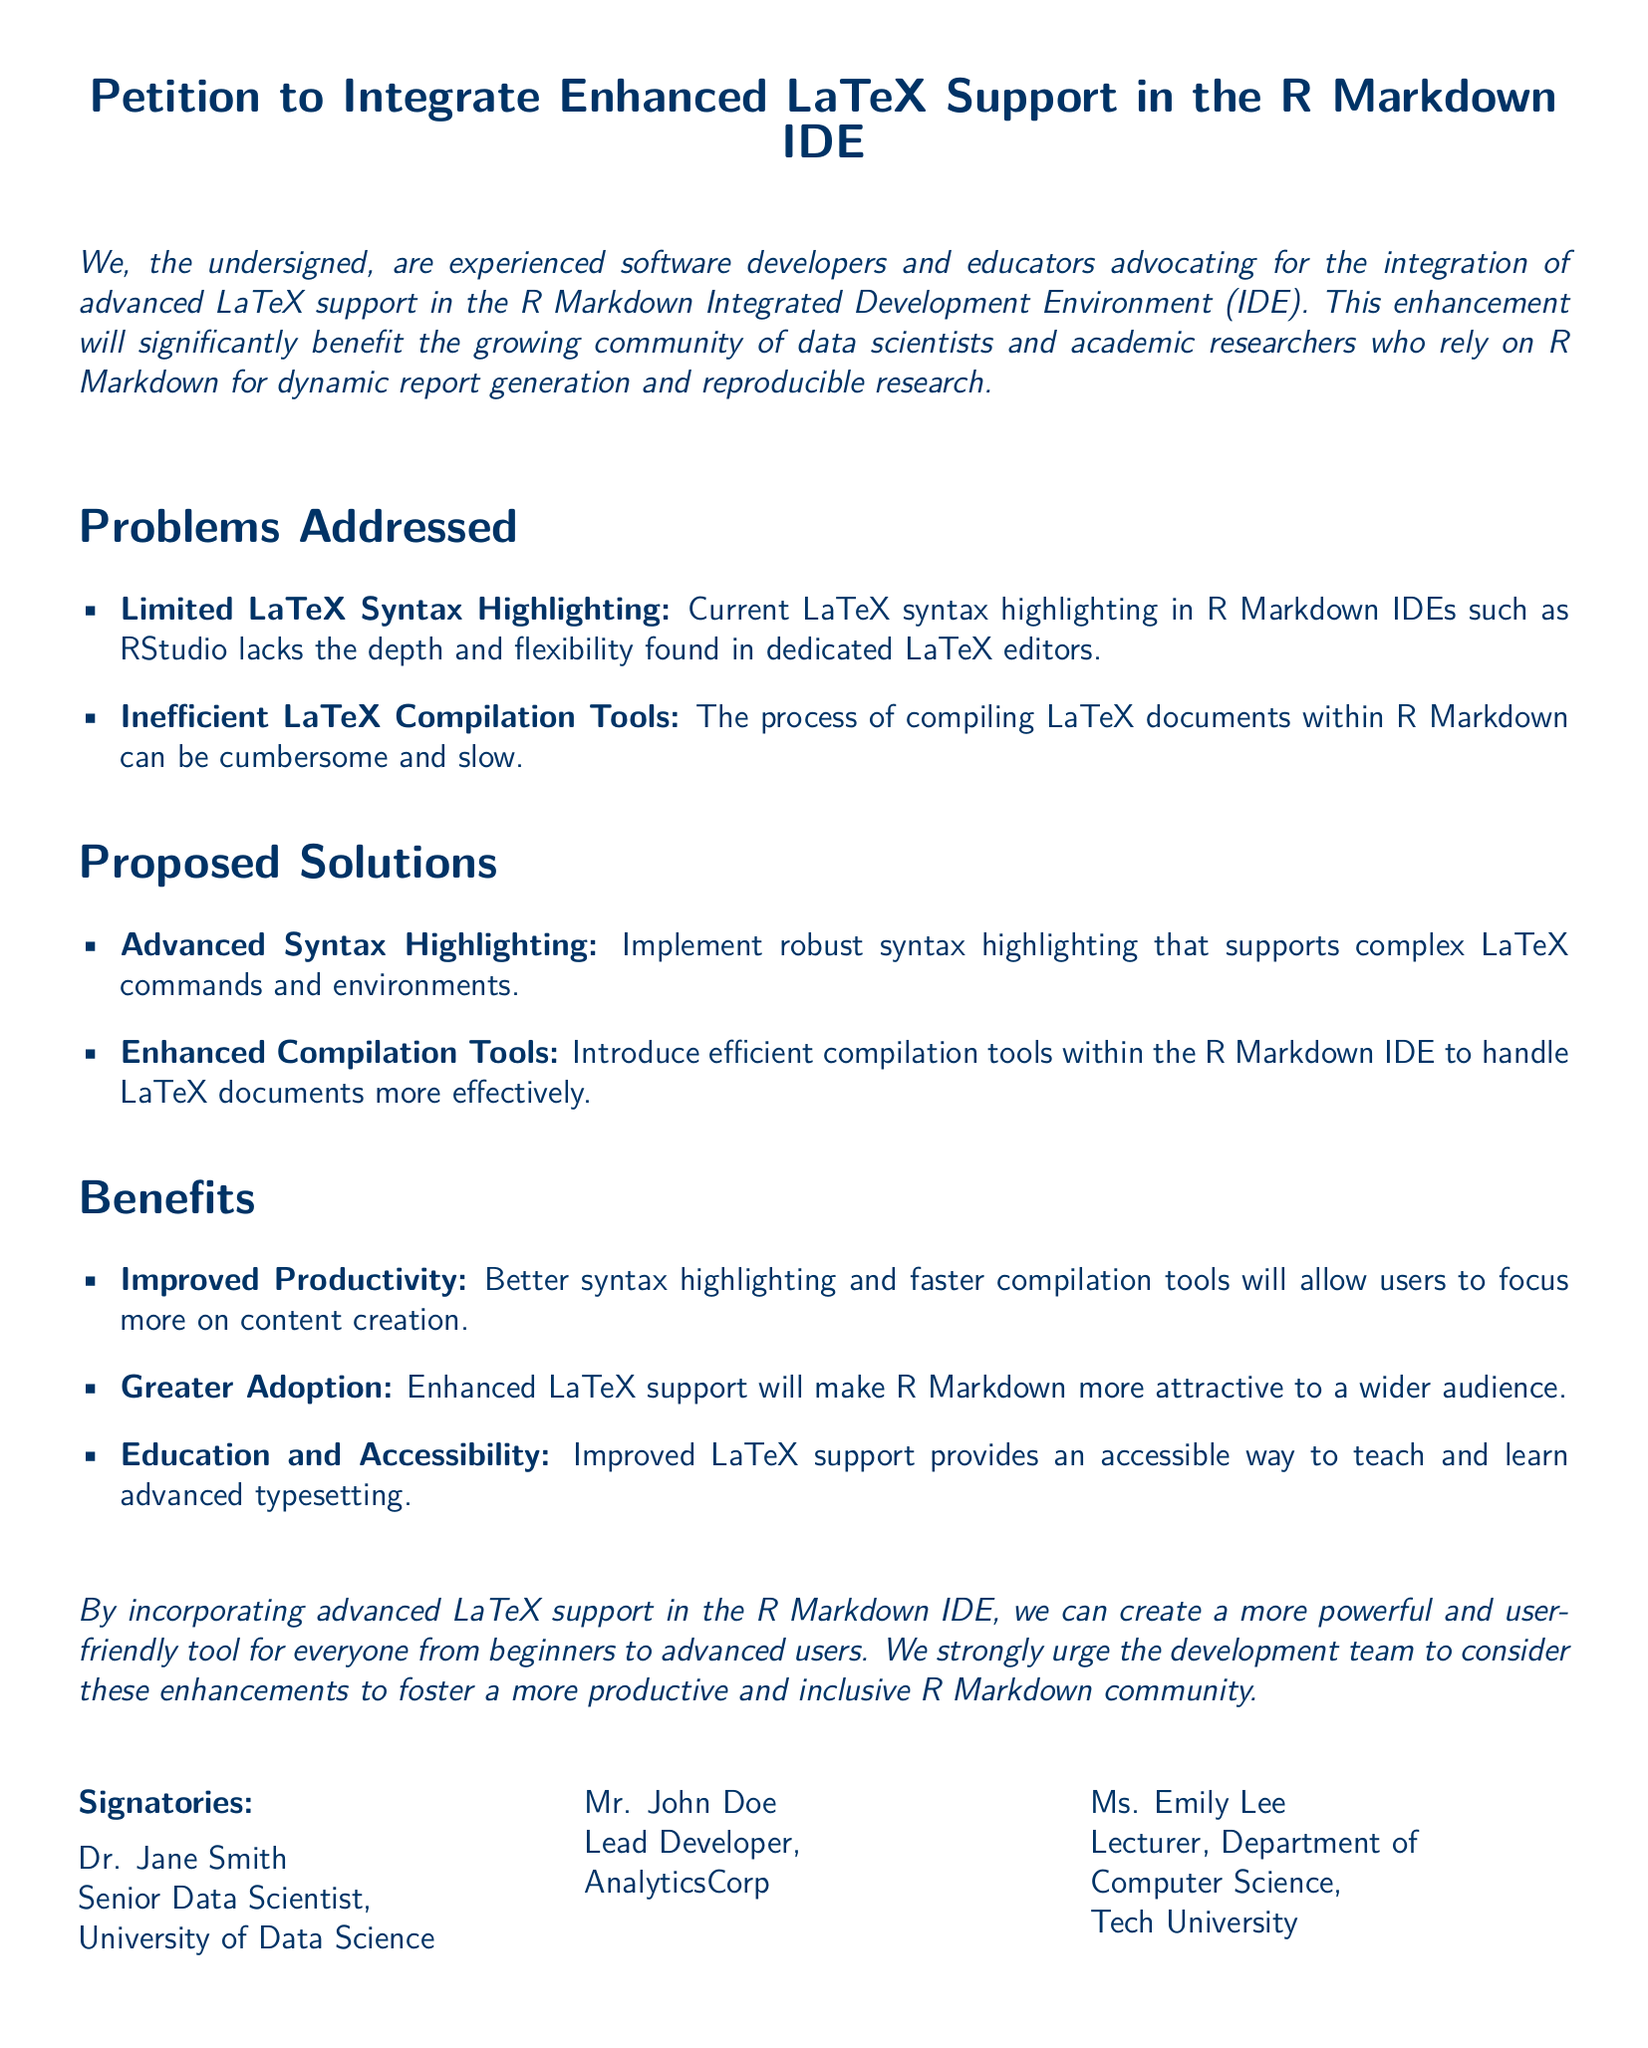What is the title of the petition? The title of the petition can be found prominently at the top of the document.
Answer: Petition to Integrate Enhanced LaTeX Support in the R Markdown IDE Who is one of the signatories? The document lists several individuals who signed the petition in the signatories section.
Answer: Dr. Jane Smith What is one problem addressed in the petition? The petition outlines specific problems related to LaTeX support in the R Markdown IDE.
Answer: Limited LaTeX Syntax Highlighting What is one proposed solution mentioned? The petition includes suggested solutions to the problems identified.
Answer: Advanced Syntax Highlighting What is the main benefit highlighted in the petition? The document lists benefits that would arise from the proposed enhancements.
Answer: Improved Productivity How many signatories are listed in the document? The signatories section includes three individuals who have endorsed the petition.
Answer: 3 What is the primary occupation of Mr. John Doe? The document specifies Mr. John Doe’s professional role in the organization he represents.
Answer: Lead Developer What kind of support does the petition advocate for? The petition stresses the need for advanced features in the R Markdown IDE.
Answer: Enhanced LaTeX Support 